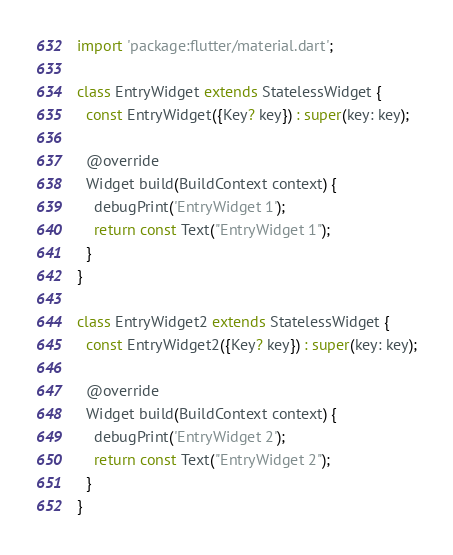<code> <loc_0><loc_0><loc_500><loc_500><_Dart_>import 'package:flutter/material.dart';

class EntryWidget extends StatelessWidget {
  const EntryWidget({Key? key}) : super(key: key);

  @override
  Widget build(BuildContext context) {
    debugPrint('EntryWidget 1');
    return const Text("EntryWidget 1");
  }
}

class EntryWidget2 extends StatelessWidget {
  const EntryWidget2({Key? key}) : super(key: key);

  @override
  Widget build(BuildContext context) {
    debugPrint('EntryWidget 2');
    return const Text("EntryWidget 2");
  }
}
</code> 